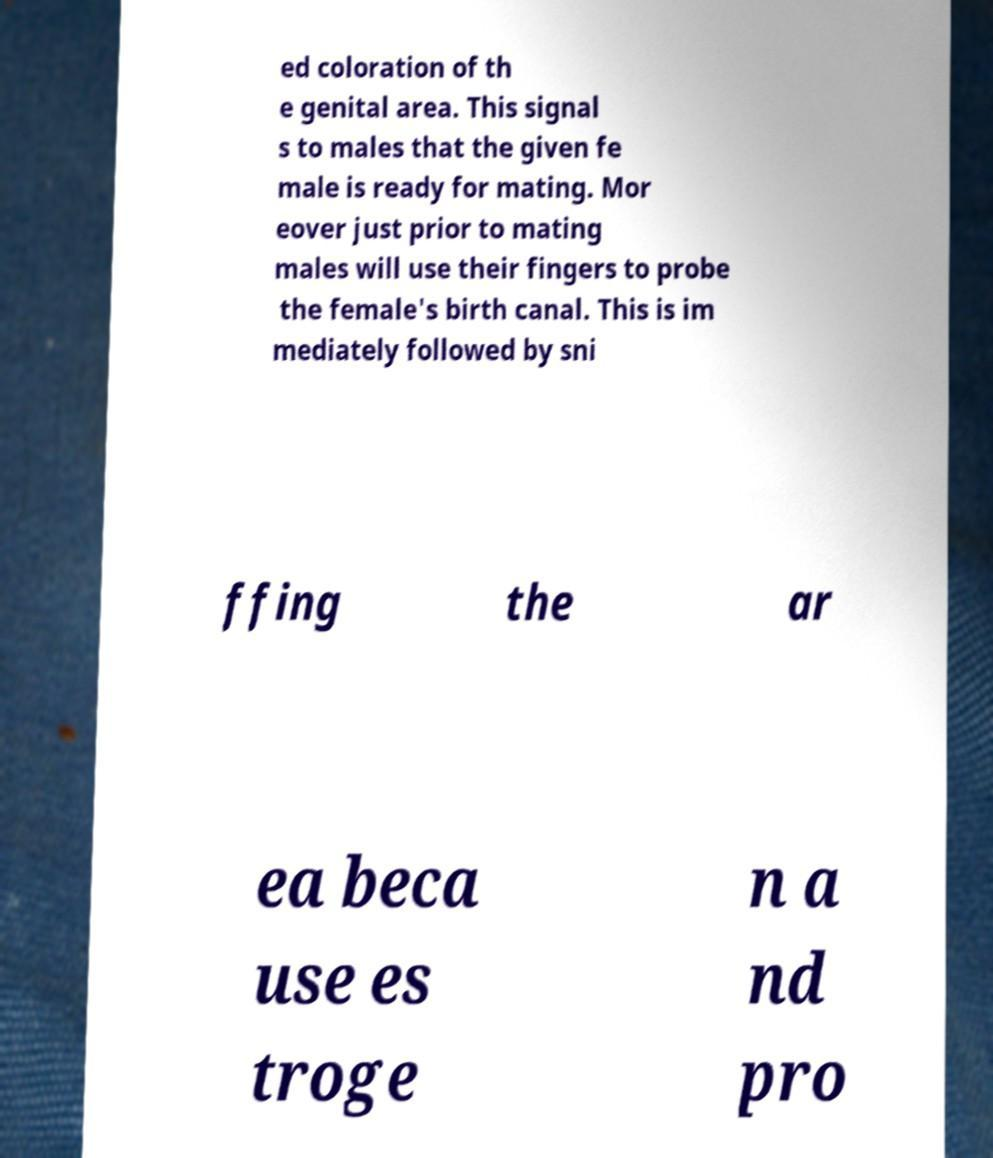Could you assist in decoding the text presented in this image and type it out clearly? ed coloration of th e genital area. This signal s to males that the given fe male is ready for mating. Mor eover just prior to mating males will use their fingers to probe the female's birth canal. This is im mediately followed by sni ffing the ar ea beca use es troge n a nd pro 